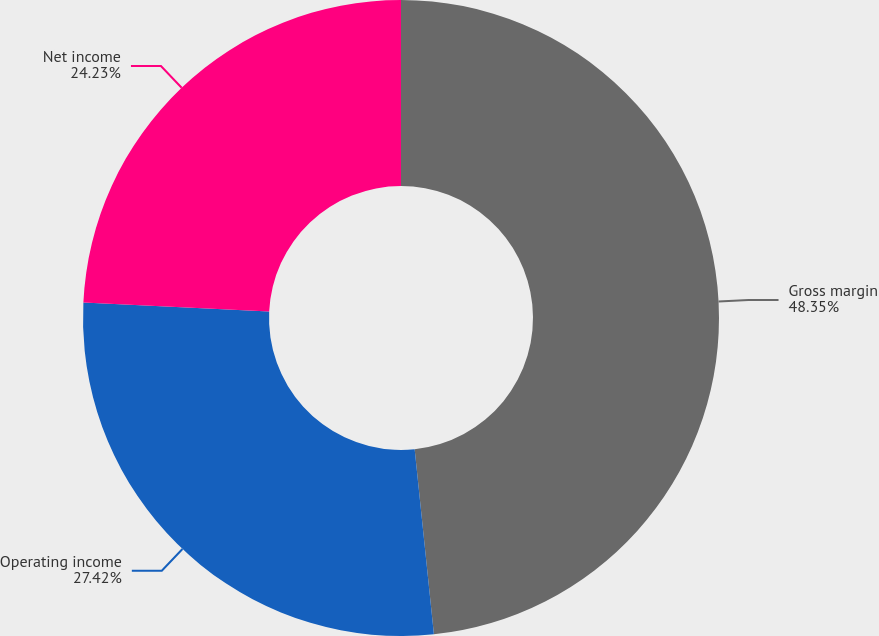<chart> <loc_0><loc_0><loc_500><loc_500><pie_chart><fcel>Gross margin<fcel>Operating income<fcel>Net income<nl><fcel>48.35%<fcel>27.42%<fcel>24.23%<nl></chart> 